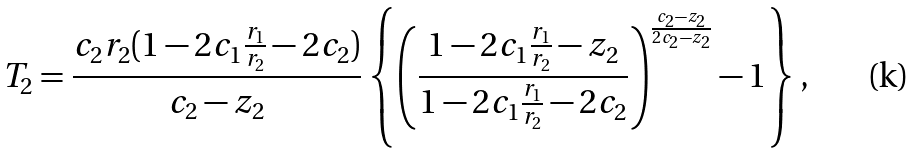<formula> <loc_0><loc_0><loc_500><loc_500>T _ { 2 } = \frac { c _ { 2 } r _ { 2 } ( 1 - 2 c _ { 1 } \frac { r _ { 1 } } { r _ { 2 } } - 2 c _ { 2 } ) } { c _ { 2 } - z _ { 2 } } \left \{ \left ( \frac { 1 - 2 c _ { 1 } \frac { r _ { 1 } } { r _ { 2 } } - z _ { 2 } } { 1 - 2 c _ { 1 } \frac { r _ { 1 } } { r _ { 2 } } - 2 c _ { 2 } } \right ) ^ { \frac { c _ { 2 } - z _ { 2 } } { 2 c _ { 2 } - z _ { 2 } } } - 1 \right \} ,</formula> 